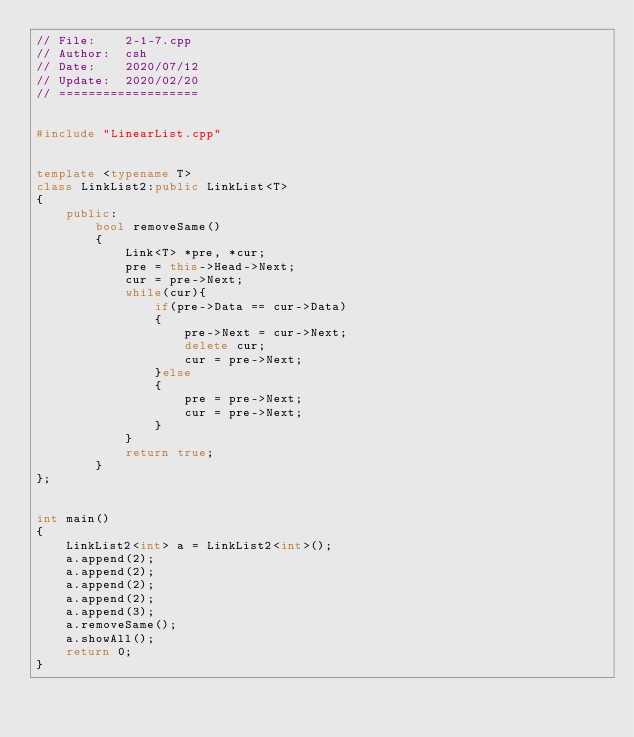<code> <loc_0><loc_0><loc_500><loc_500><_C++_>// File:    2-1-7.cpp
// Author:  csh
// Date:    2020/07/12
// Update:  2020/02/20
// ===================


#include "LinearList.cpp"


template <typename T>
class LinkList2:public LinkList<T>
{
    public:
        bool removeSame()
        {
            Link<T> *pre, *cur;
            pre = this->Head->Next;
            cur = pre->Next;
            while(cur){
                if(pre->Data == cur->Data)
                {
                    pre->Next = cur->Next;
                    delete cur;
                    cur = pre->Next;
                }else
                {
                    pre = pre->Next;
                    cur = pre->Next;
                }
            }
            return true;
        }
};


int main()
{
    LinkList2<int> a = LinkList2<int>();
    a.append(2);
    a.append(2);
    a.append(2);
    a.append(2);
    a.append(3);
    a.removeSame();
    a.showAll();
    return 0;
}
</code> 